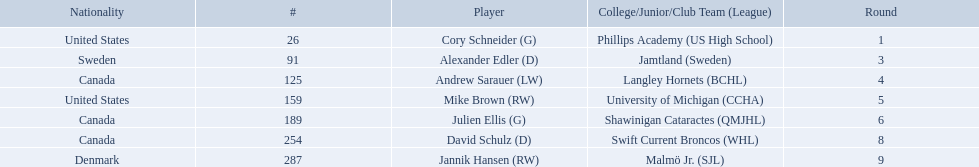What are the nationalities of the players? United States, Sweden, Canada, United States, Canada, Canada, Denmark. Of the players, which one lists his nationality as denmark? Jannik Hansen (RW). 